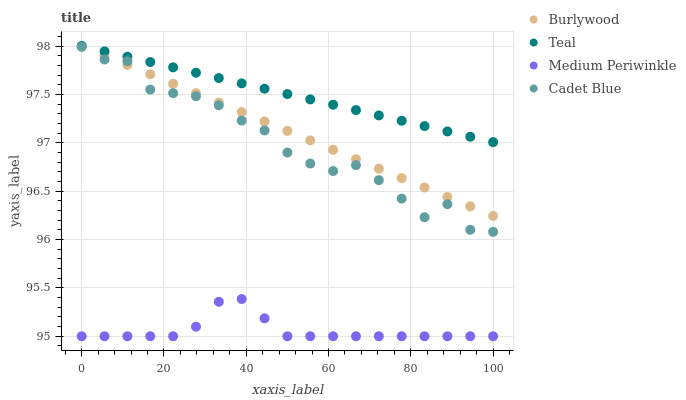Does Medium Periwinkle have the minimum area under the curve?
Answer yes or no. Yes. Does Teal have the maximum area under the curve?
Answer yes or no. Yes. Does Cadet Blue have the minimum area under the curve?
Answer yes or no. No. Does Cadet Blue have the maximum area under the curve?
Answer yes or no. No. Is Burlywood the smoothest?
Answer yes or no. Yes. Is Cadet Blue the roughest?
Answer yes or no. Yes. Is Medium Periwinkle the smoothest?
Answer yes or no. No. Is Medium Periwinkle the roughest?
Answer yes or no. No. Does Medium Periwinkle have the lowest value?
Answer yes or no. Yes. Does Cadet Blue have the lowest value?
Answer yes or no. No. Does Teal have the highest value?
Answer yes or no. Yes. Does Cadet Blue have the highest value?
Answer yes or no. No. Is Medium Periwinkle less than Teal?
Answer yes or no. Yes. Is Cadet Blue greater than Medium Periwinkle?
Answer yes or no. Yes. Does Burlywood intersect Teal?
Answer yes or no. Yes. Is Burlywood less than Teal?
Answer yes or no. No. Is Burlywood greater than Teal?
Answer yes or no. No. Does Medium Periwinkle intersect Teal?
Answer yes or no. No. 